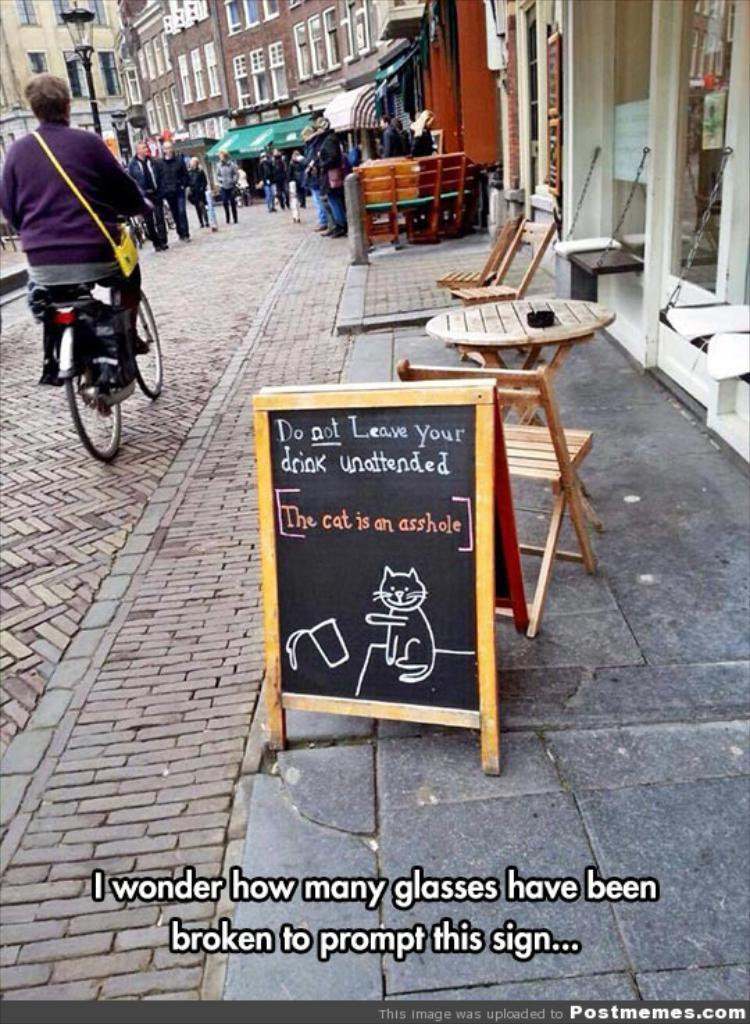What type of location is depicted in the image? There is a street in the image. What can be found along the street? There are shops along the street. What else can be seen in the image besides the street and shops? There are buildings, a street lamp, people walking, one person riding a bicycle, tables and chairs, and a board. How many trains can be seen in the image? There are no trains present in the image. Is the street in the image known for its quiet atmosphere? The image does not provide information about the noise level or atmosphere of the street. 